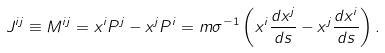<formula> <loc_0><loc_0><loc_500><loc_500>J ^ { i j } \equiv M ^ { i j } = x ^ { i } P ^ { j } - x ^ { j } P ^ { i } = m \sigma ^ { - 1 } \left ( x ^ { i } \frac { d x ^ { j } } { d s } - x ^ { j } \frac { d x ^ { i } } { d s } \right ) .</formula> 